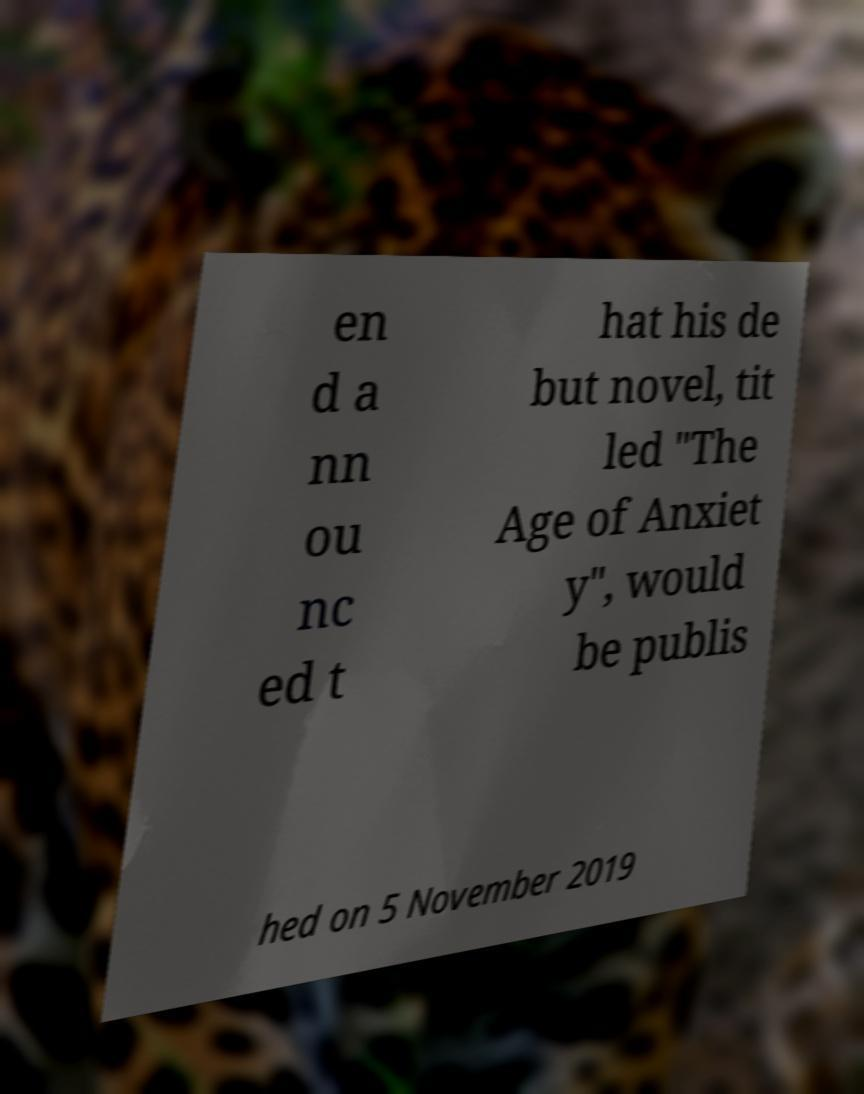Could you extract and type out the text from this image? en d a nn ou nc ed t hat his de but novel, tit led "The Age of Anxiet y", would be publis hed on 5 November 2019 